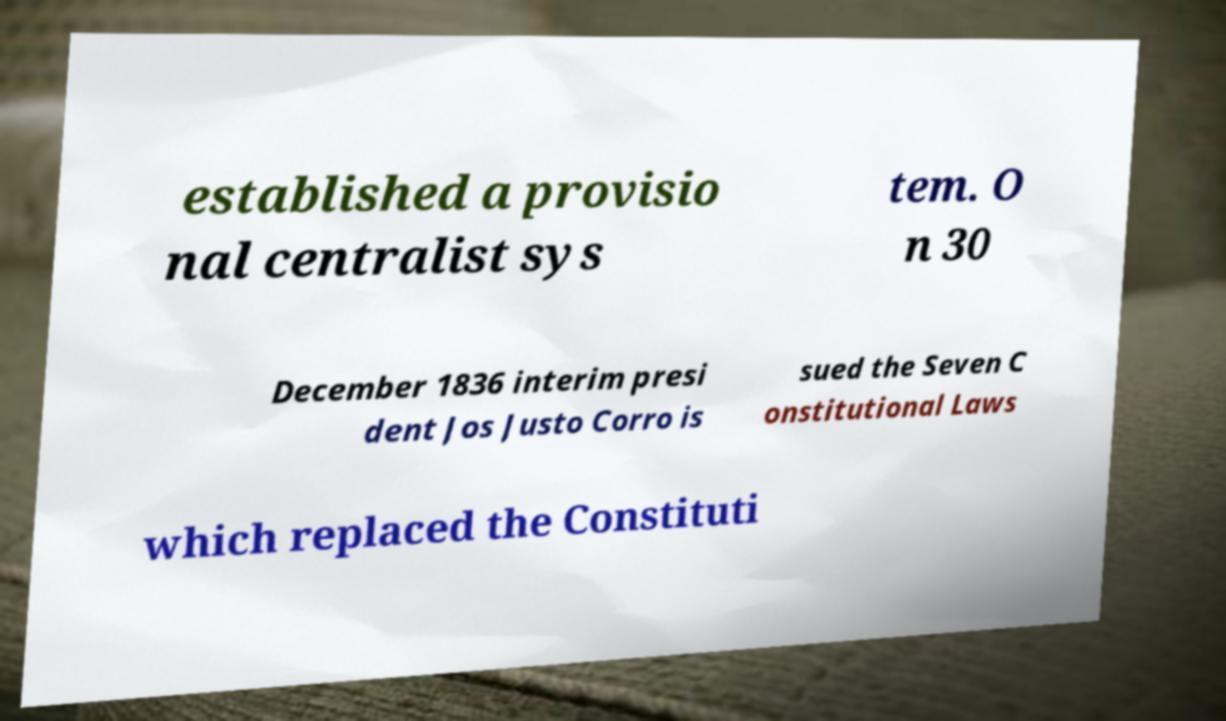Can you read and provide the text displayed in the image?This photo seems to have some interesting text. Can you extract and type it out for me? established a provisio nal centralist sys tem. O n 30 December 1836 interim presi dent Jos Justo Corro is sued the Seven C onstitutional Laws which replaced the Constituti 